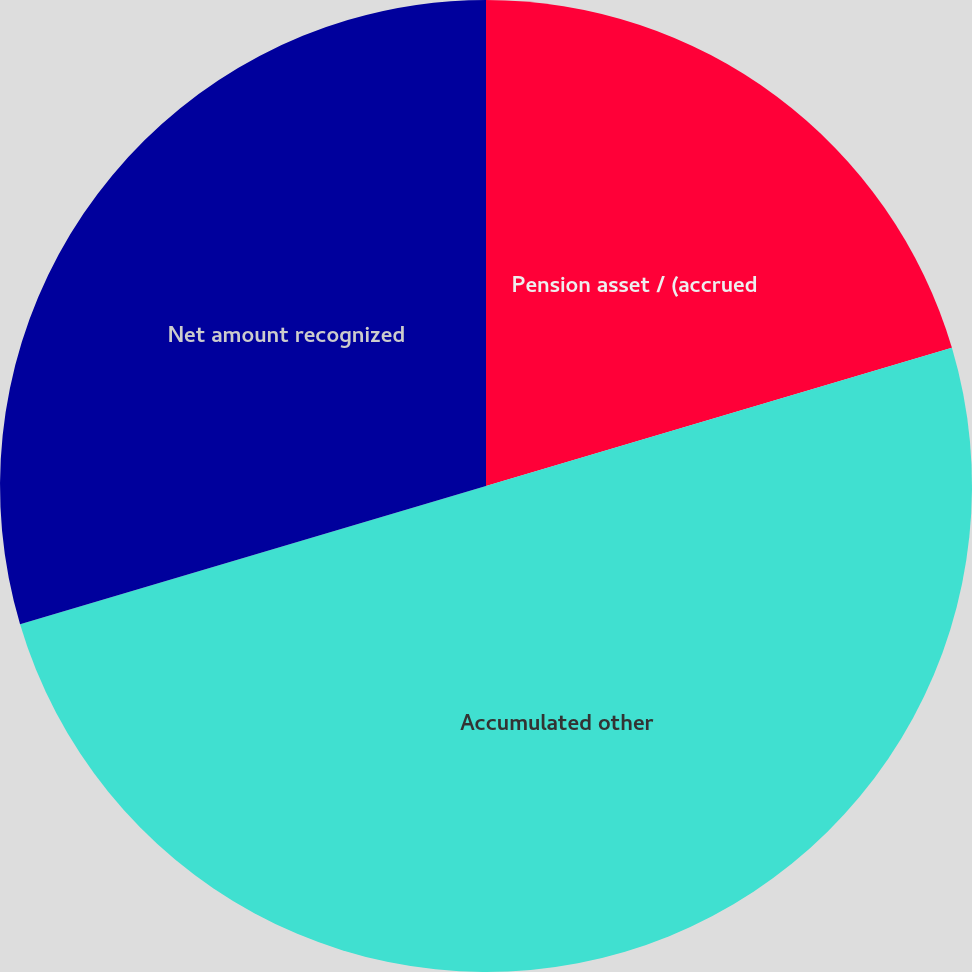Convert chart to OTSL. <chart><loc_0><loc_0><loc_500><loc_500><pie_chart><fcel>Pension asset / (accrued<fcel>Accumulated other<fcel>Net amount recognized<nl><fcel>20.41%<fcel>50.0%<fcel>29.59%<nl></chart> 